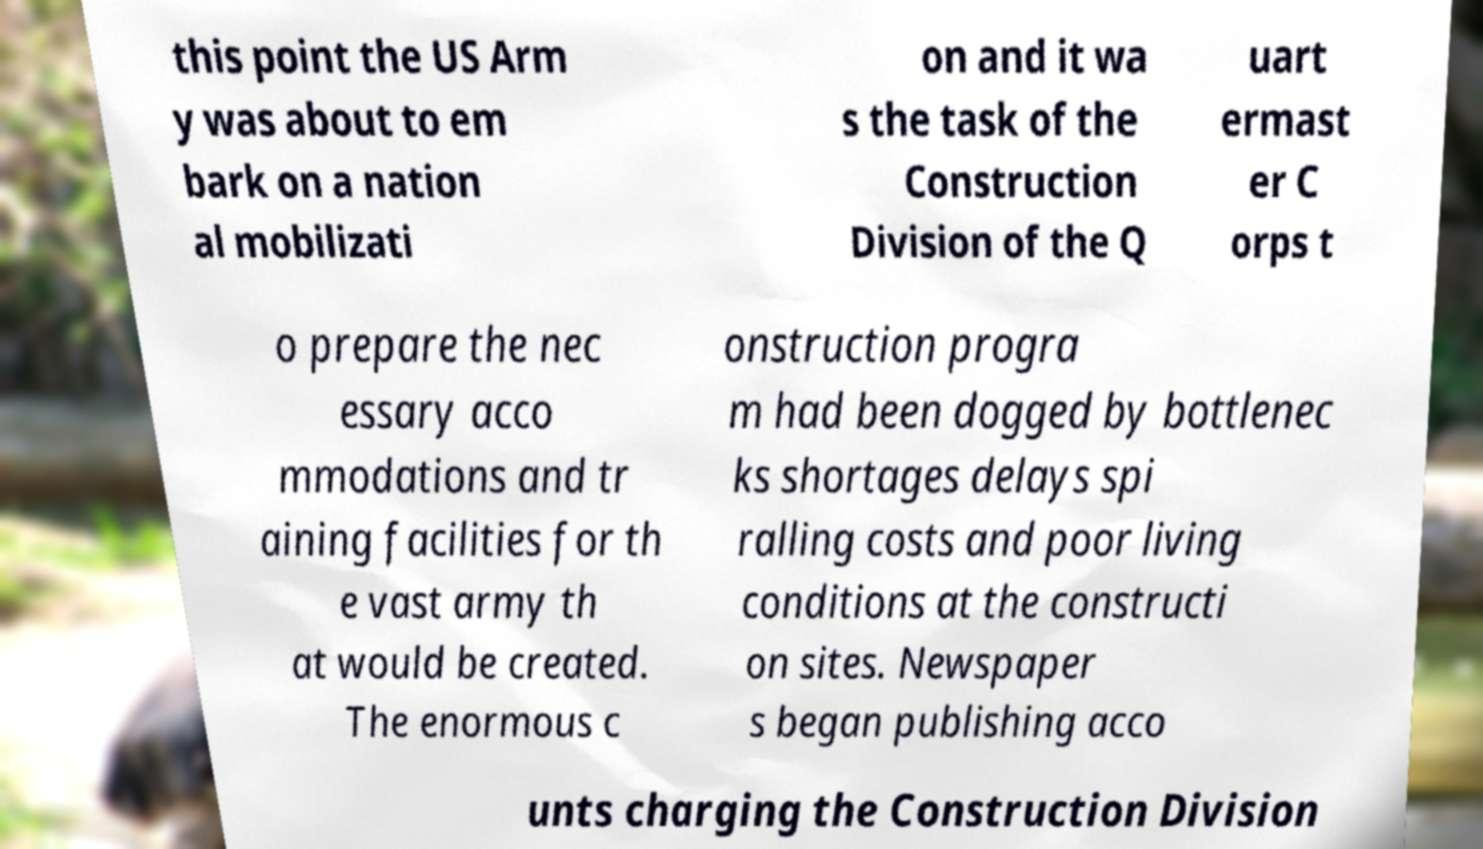For documentation purposes, I need the text within this image transcribed. Could you provide that? this point the US Arm y was about to em bark on a nation al mobilizati on and it wa s the task of the Construction Division of the Q uart ermast er C orps t o prepare the nec essary acco mmodations and tr aining facilities for th e vast army th at would be created. The enormous c onstruction progra m had been dogged by bottlenec ks shortages delays spi ralling costs and poor living conditions at the constructi on sites. Newspaper s began publishing acco unts charging the Construction Division 